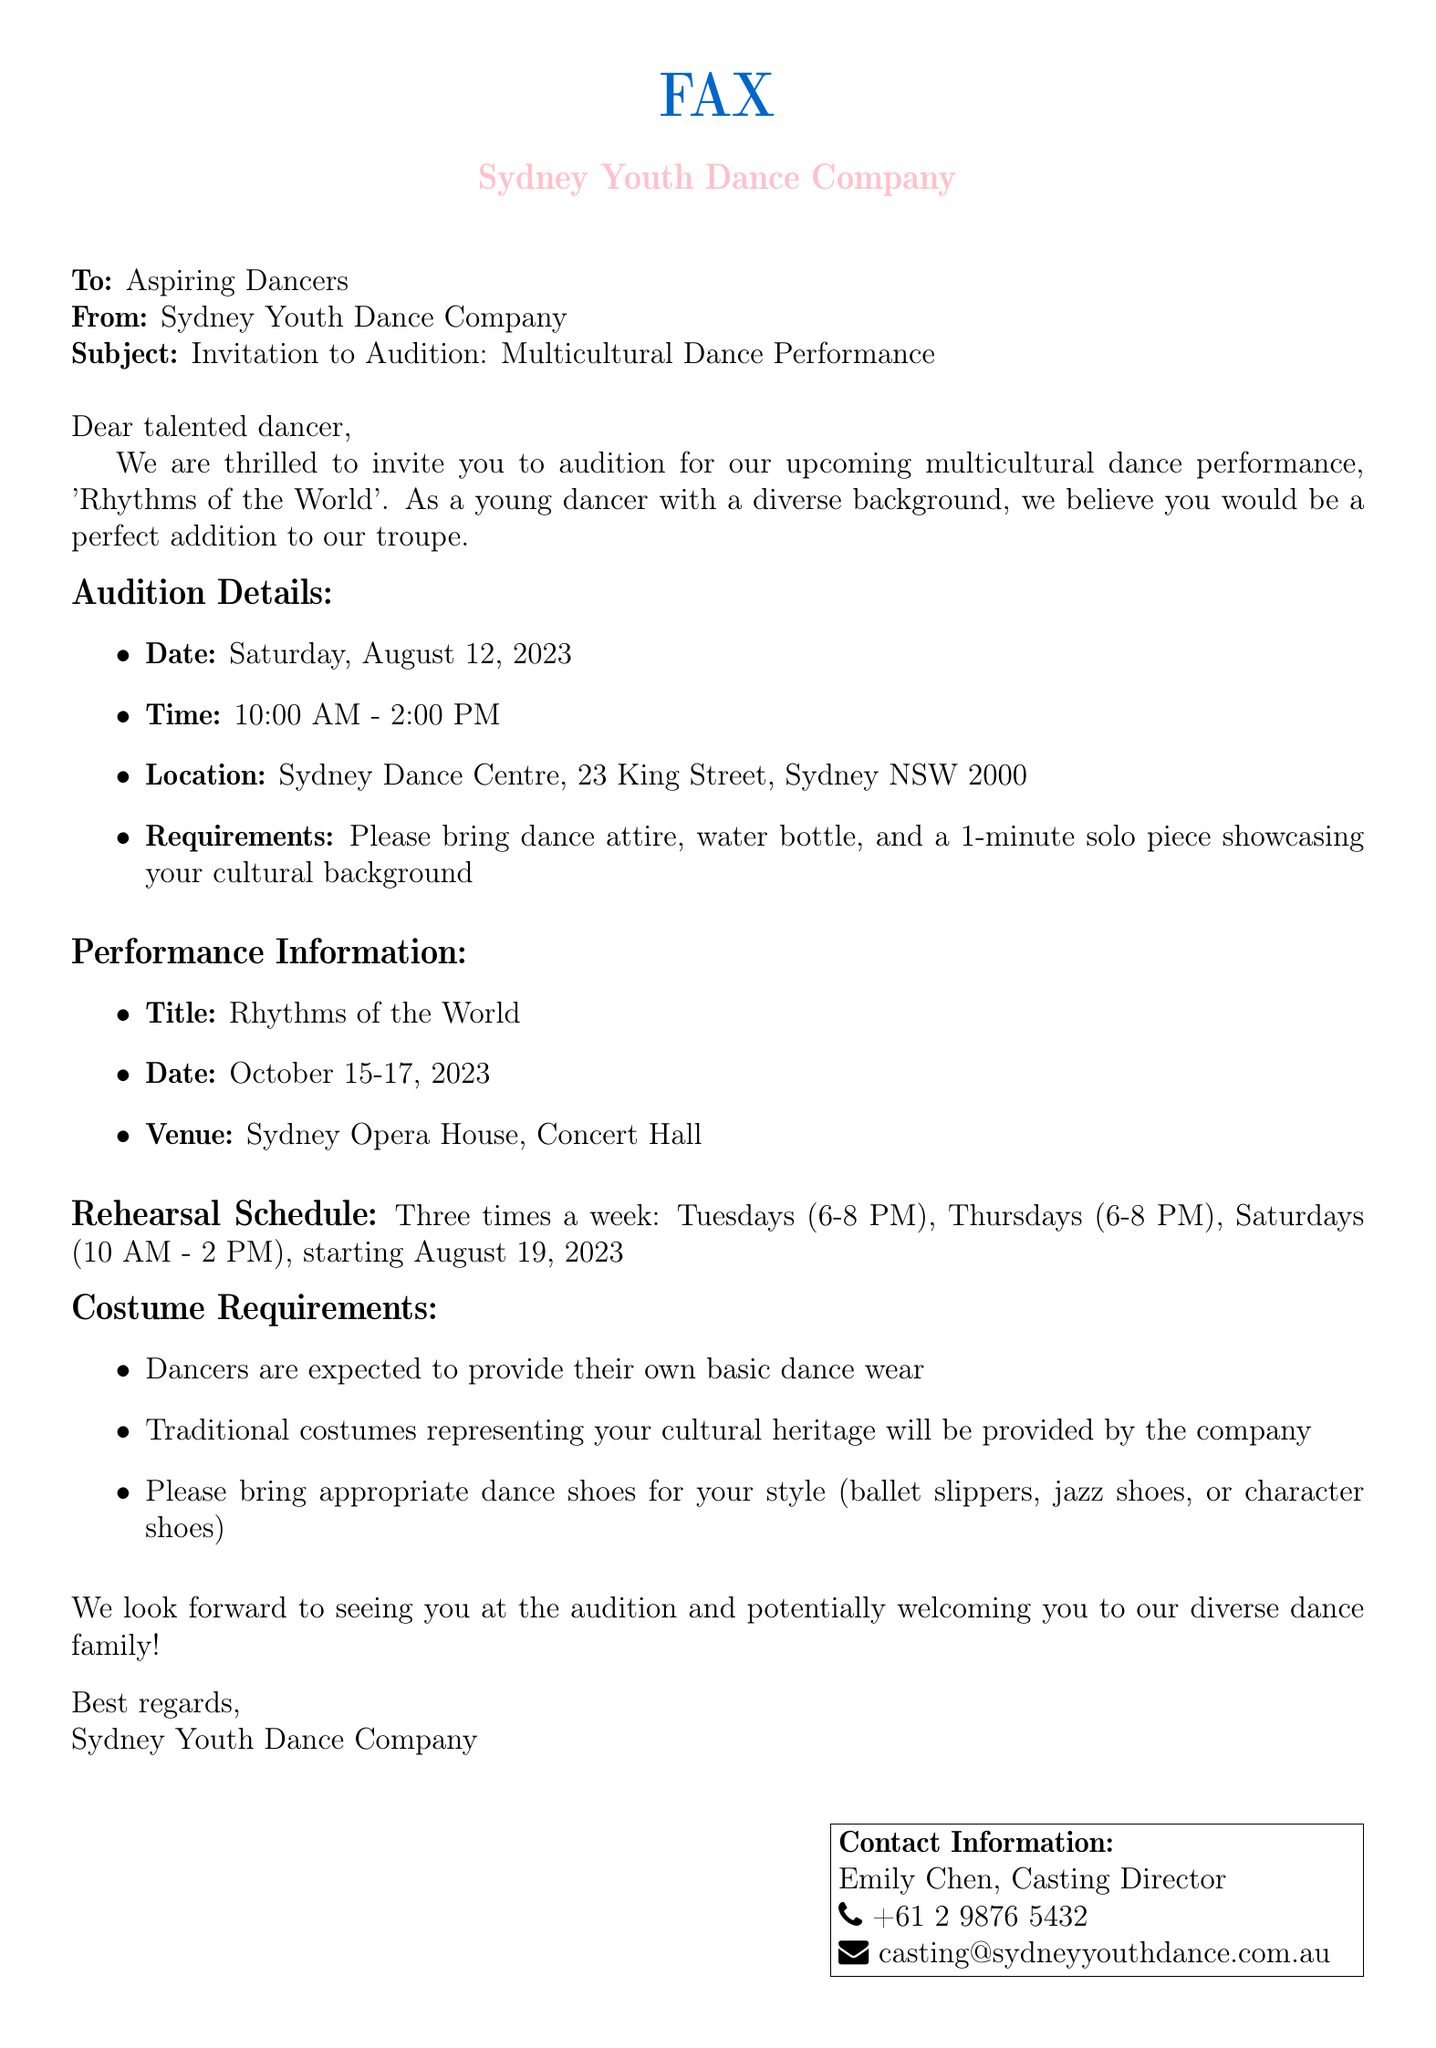What is the title of the performance? The title of the performance is specified in the document as 'Rhythms of the World'.
Answer: Rhythms of the World When is the audition date? The audition date is listed in the document as Saturday, August 12, 2023.
Answer: Saturday, August 12, 2023 What time do rehearsals start? The document provides the rehearsal schedule, indicating that rehearsals start at 6 PM on Tuesdays and Thursdays and 10 AM on Saturdays.
Answer: 6 PM What is the location of the auditions? The location for the auditions is mentioned as Sydney Dance Centre, 23 King Street, Sydney NSW 2000.
Answer: Sydney Dance Centre, 23 King Street, Sydney NSW 2000 How many times a week are the rehearsals? The document outlines that rehearsals occur three times a week.
Answer: Three times What should dancers bring to the auditions? The document indicates that dancers should bring dance attire, a water bottle, and a 1-minute solo piece showcasing their cultural background.
Answer: Dance attire, water bottle, 1-minute solo piece Who is the casting director’s contact person? The casting director's name is specified in the document as Emily Chen.
Answer: Emily Chen What are the performance dates? The performance dates are provided in the document as October 15-17, 2023.
Answer: October 15-17, 2023 